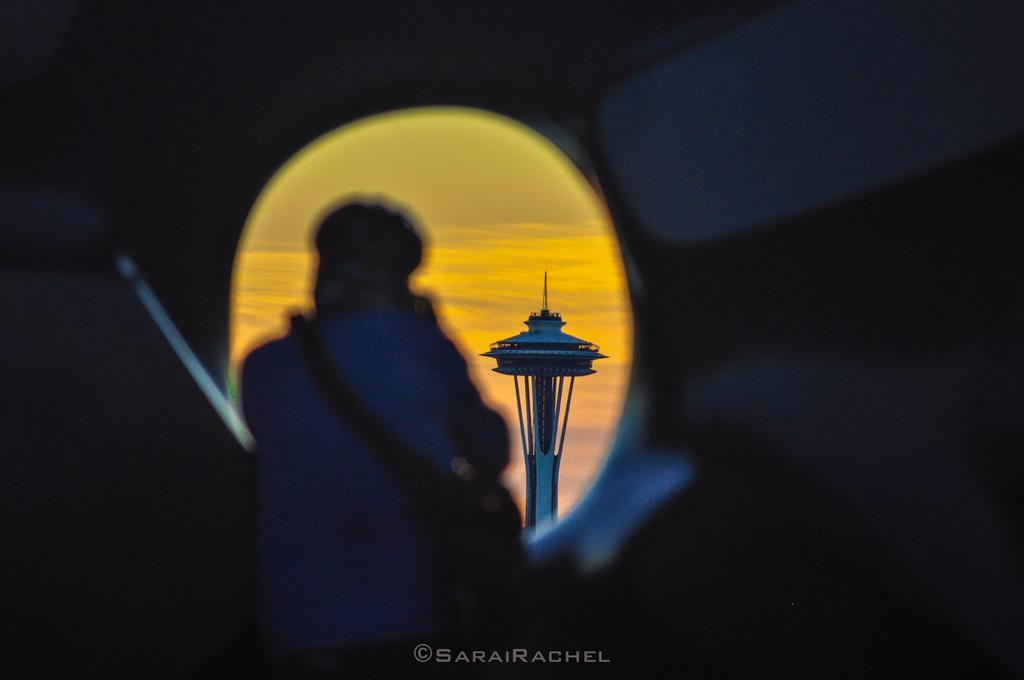In one or two sentences, can you explain what this image depicts? In the picture I can see a tower, a person and some other things. This picture is little bit dark. I can also see a watermark on the bottom side of the image. 